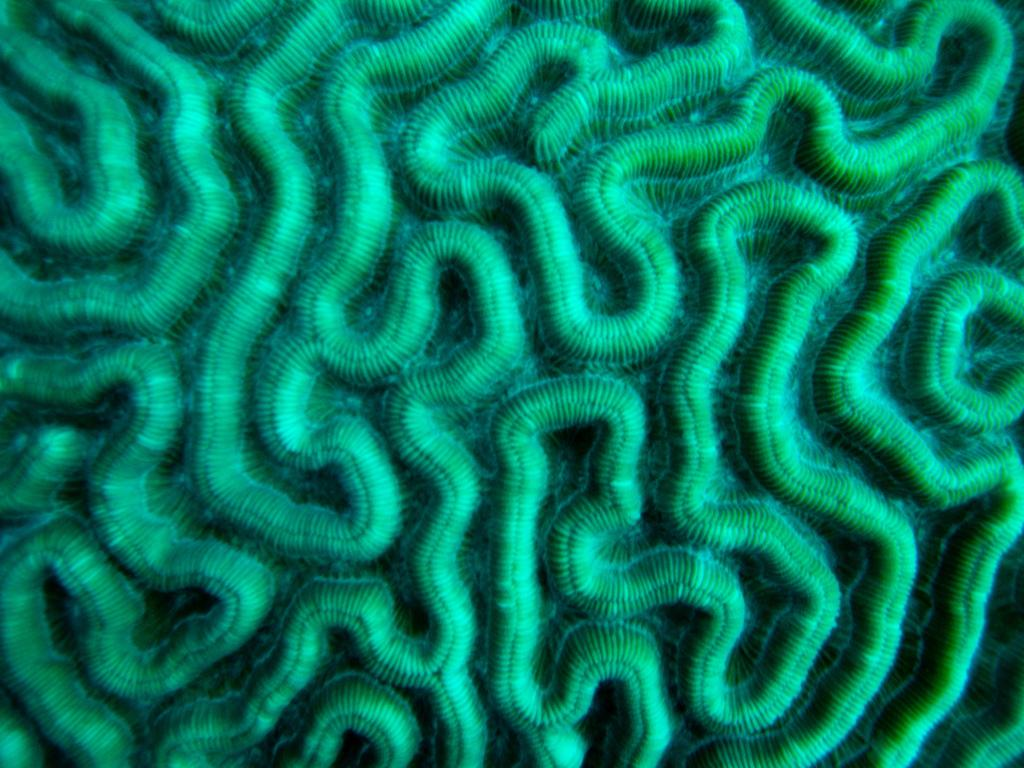What is the dominant color in the pattern visible in the image? The dominant color in the pattern is green. What type of fowl can be seen taking action in the image? There is no fowl present in the image, and no action is taking place. 